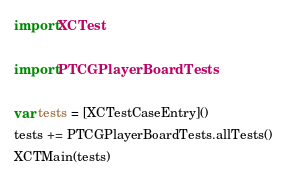Convert code to text. <code><loc_0><loc_0><loc_500><loc_500><_Swift_>import XCTest

import PTCGPlayerBoardTests

var tests = [XCTestCaseEntry]()
tests += PTCGPlayerBoardTests.allTests()
XCTMain(tests)
</code> 